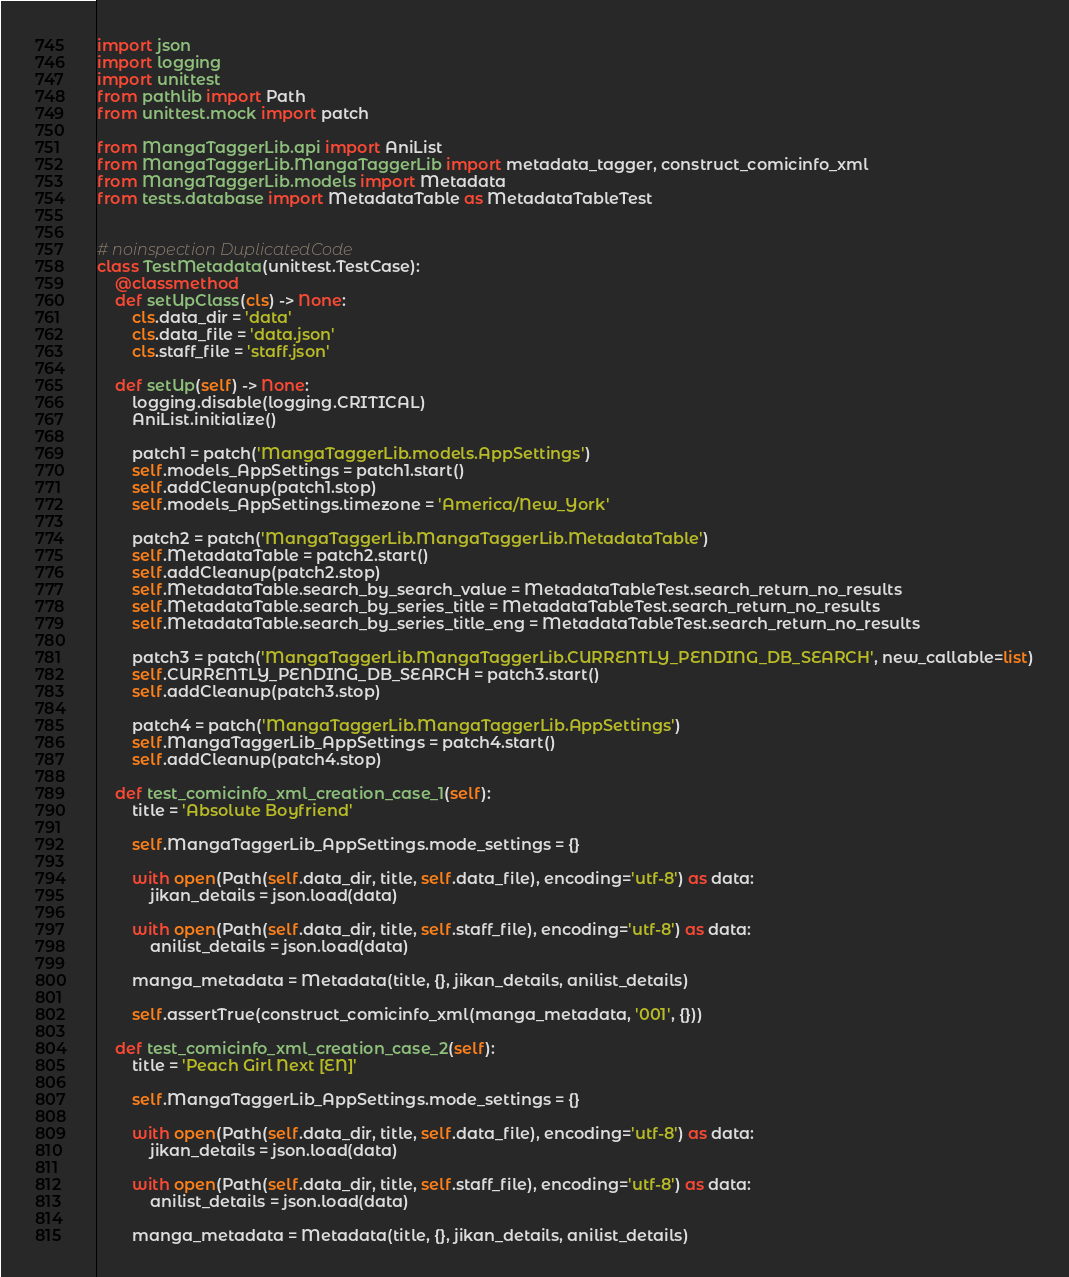Convert code to text. <code><loc_0><loc_0><loc_500><loc_500><_Python_>import json
import logging
import unittest
from pathlib import Path
from unittest.mock import patch

from MangaTaggerLib.api import AniList
from MangaTaggerLib.MangaTaggerLib import metadata_tagger, construct_comicinfo_xml
from MangaTaggerLib.models import Metadata
from tests.database import MetadataTable as MetadataTableTest


# noinspection DuplicatedCode
class TestMetadata(unittest.TestCase):
    @classmethod
    def setUpClass(cls) -> None:
        cls.data_dir = 'data'
        cls.data_file = 'data.json'
        cls.staff_file = 'staff.json'

    def setUp(self) -> None:
        logging.disable(logging.CRITICAL)
        AniList.initialize()

        patch1 = patch('MangaTaggerLib.models.AppSettings')
        self.models_AppSettings = patch1.start()
        self.addCleanup(patch1.stop)
        self.models_AppSettings.timezone = 'America/New_York'

        patch2 = patch('MangaTaggerLib.MangaTaggerLib.MetadataTable')
        self.MetadataTable = patch2.start()
        self.addCleanup(patch2.stop)
        self.MetadataTable.search_by_search_value = MetadataTableTest.search_return_no_results
        self.MetadataTable.search_by_series_title = MetadataTableTest.search_return_no_results
        self.MetadataTable.search_by_series_title_eng = MetadataTableTest.search_return_no_results

        patch3 = patch('MangaTaggerLib.MangaTaggerLib.CURRENTLY_PENDING_DB_SEARCH', new_callable=list)
        self.CURRENTLY_PENDING_DB_SEARCH = patch3.start()
        self.addCleanup(patch3.stop)

        patch4 = patch('MangaTaggerLib.MangaTaggerLib.AppSettings')
        self.MangaTaggerLib_AppSettings = patch4.start()
        self.addCleanup(patch4.stop)

    def test_comicinfo_xml_creation_case_1(self):
        title = 'Absolute Boyfriend'

        self.MangaTaggerLib_AppSettings.mode_settings = {}

        with open(Path(self.data_dir, title, self.data_file), encoding='utf-8') as data:
            jikan_details = json.load(data)

        with open(Path(self.data_dir, title, self.staff_file), encoding='utf-8') as data:
            anilist_details = json.load(data)

        manga_metadata = Metadata(title, {}, jikan_details, anilist_details)

        self.assertTrue(construct_comicinfo_xml(manga_metadata, '001', {}))

    def test_comicinfo_xml_creation_case_2(self):
        title = 'Peach Girl Next [EN]'

        self.MangaTaggerLib_AppSettings.mode_settings = {}

        with open(Path(self.data_dir, title, self.data_file), encoding='utf-8') as data:
            jikan_details = json.load(data)

        with open(Path(self.data_dir, title, self.staff_file), encoding='utf-8') as data:
            anilist_details = json.load(data)

        manga_metadata = Metadata(title, {}, jikan_details, anilist_details)
</code> 